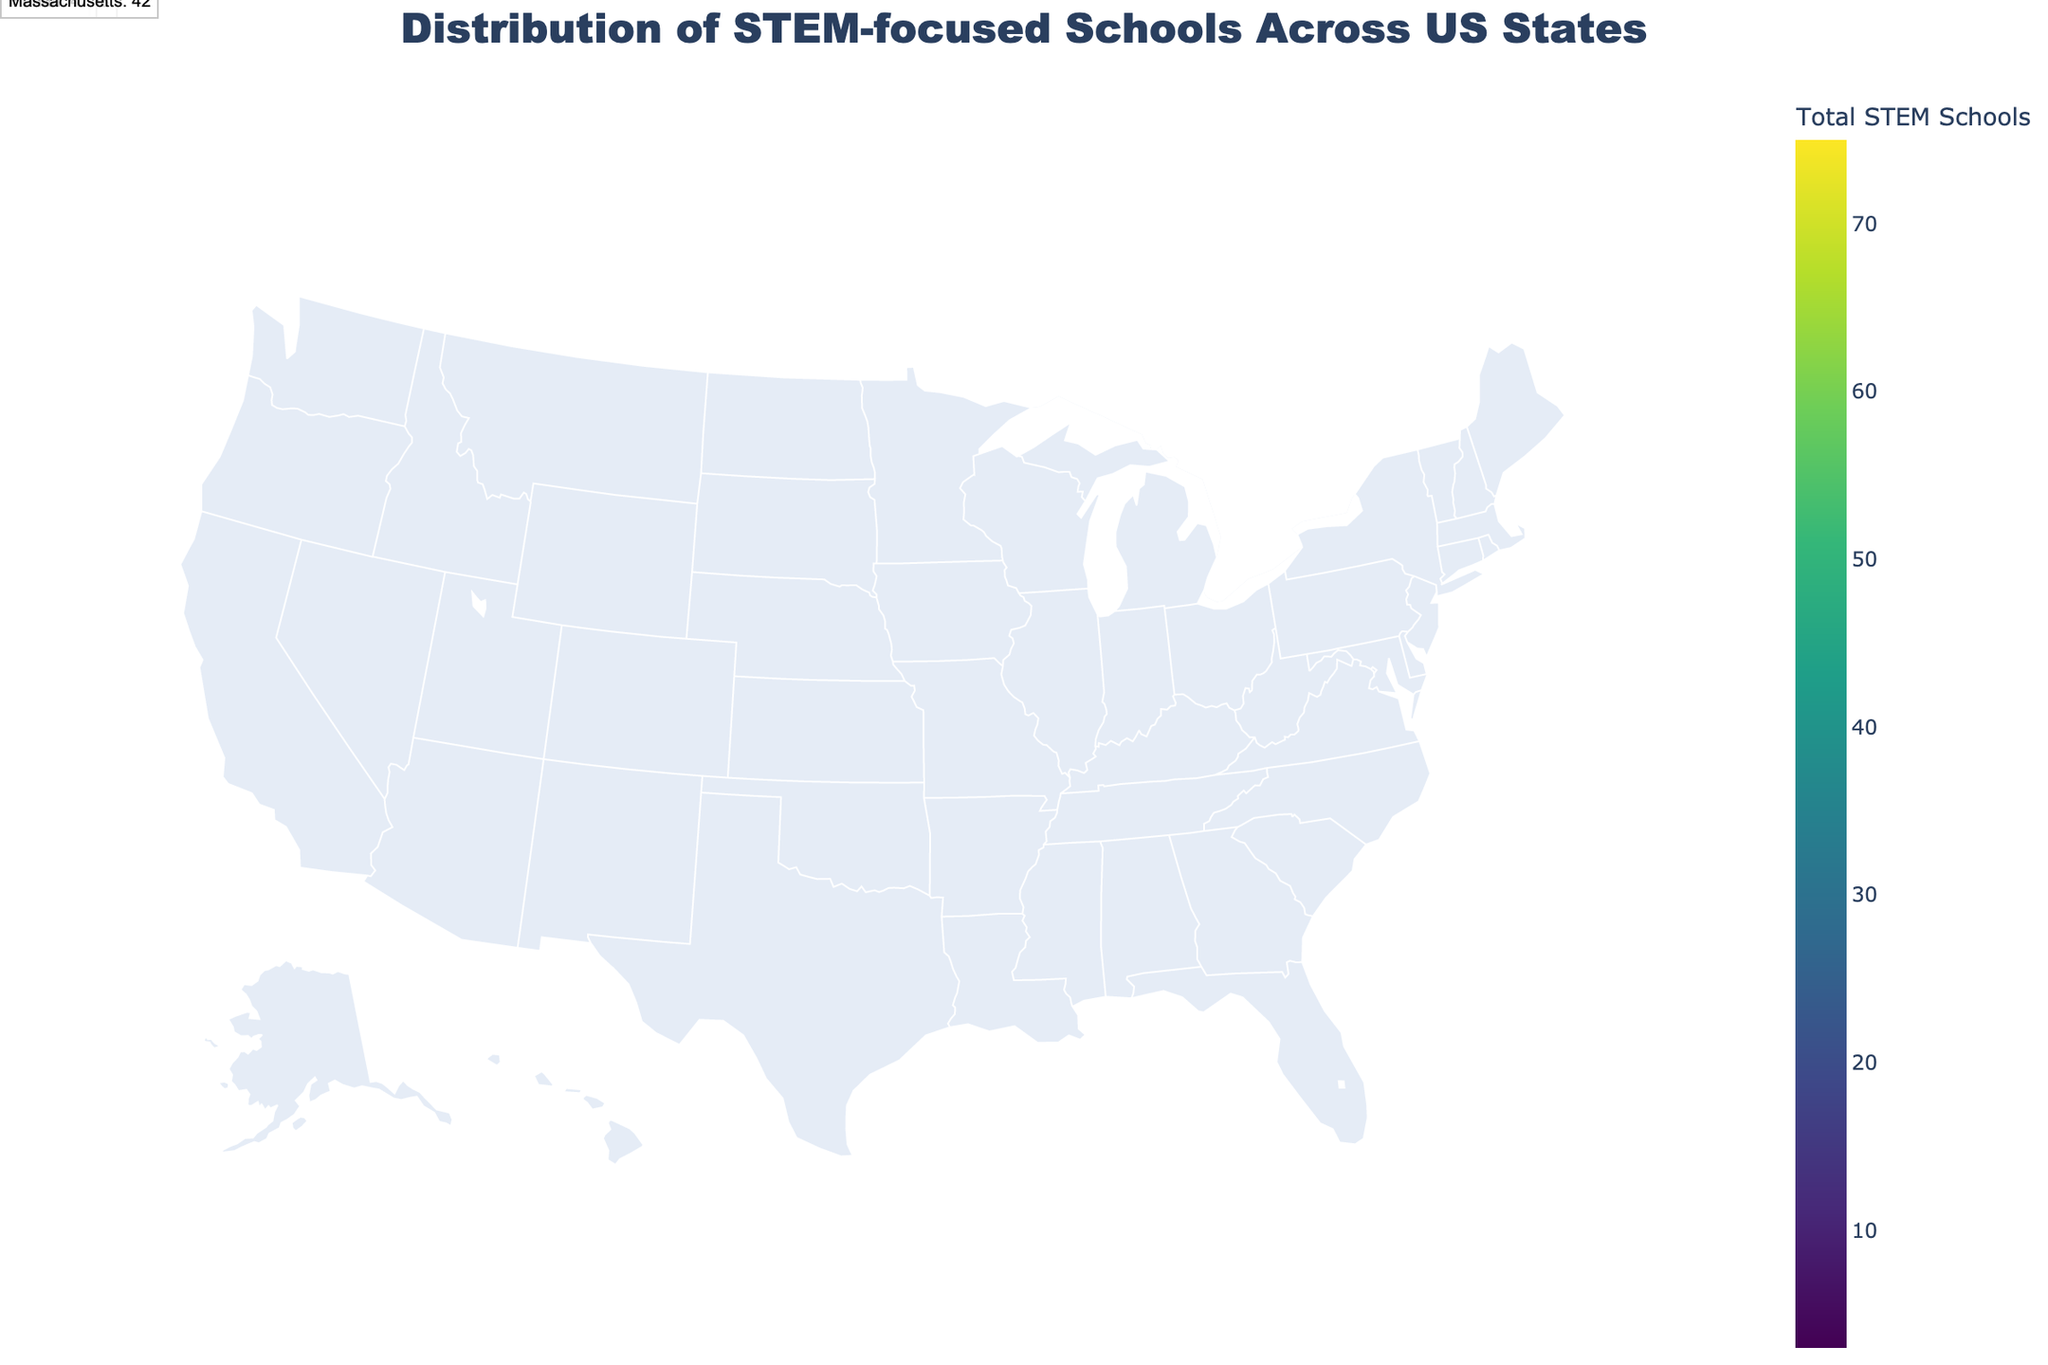What state has the highest number of STEM-focused schools? The figure shows a choropleth map color-coding states based on the total number of STEM-focused schools. Hovering over states provides detailed counts. California stands out with the darkest shade, indicating the highest count.
Answer: California How many private STEM-focused schools are there in New York? Hovering over New York on the map displays detailed numbers for Public, Private, and Charter STEM schools. The number of Private STEM schools in New York is provided as part of this hover data.
Answer: 22 What's the total number of STEM-focused schools in Texas, combining public, private, and charter ones? The hover data for Texas shows individual counts for Public, Private, and Charter STEM schools. Summing these values gives the total number of STEM-focused schools in Texas.
Answer: 57 Which state has more Charter STEM schools, Florida or Illinois? Hovering over both Florida and Illinois provides the number of Charter STEM schools in each state. Comparing these numbers, Florida has more Charter STEM schools than Illinois.
Answer: Florida What's the median number of Public STEM-focused schools across all states? Listing the numbers of Public STEM schools for each state and sorting them: (1, 2, 3, 4, 5, 6, 7, 8, 9, 10, 11, 12, 14, 15, 18, 20, 25, 28, 35, 42), the median is the average of the 10th and 11th values (10 and 11).
Answer: 10.5 Which state ranks fifth in total STEM-focused schools? By examining the annotations for the top 5 states in the figure, each state's total STEM schools are noted. The fifth state listed is Massachusetts.
Answer: Massachusetts Is the number of Public STEM schools greater than the total number of STEM schools in New Jersey? Comparing California's Public STEM schools (42) with New Jersey's total STEM schools (14), California's count is greater.
Answer: Yes Which state has the lowest total number of STEM-focused schools? Identifying the state with the lightest shade on the choropleth map, Oregon is noted as having the lowest count, confirmed by the hover data.
Answer: Oregon How does the number of private STEM schools in Massachusetts compare to those in Illinois? Hovering over Massachusetts and Illinois reveals the private STEM schools count for each. Massachusetts has 15, while Illinois has 8, indicating Massachusetts has more.
Answer: Massachusetts How many states have at least 10 public STEM-focused schools? Counting the states where the number of Public STEM schools is at least 10 by hovering over each state, there are 7 such states.
Answer: 7 